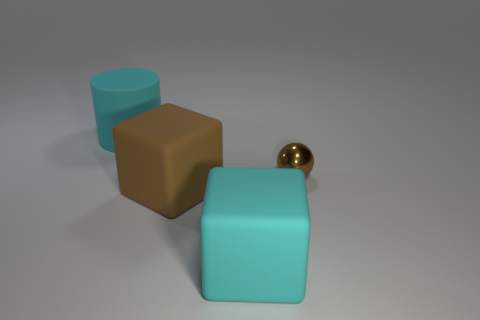There is a small metal thing on the right side of the large cyan thing that is in front of the large brown rubber cube; what is its color?
Your answer should be compact. Brown. How many other things are the same material as the small thing?
Provide a short and direct response. 0. Are there an equal number of small metal objects that are left of the cyan matte cylinder and large brown shiny cylinders?
Keep it short and to the point. Yes. What is the material of the big block behind the large cyan thing on the right side of the cylinder that is on the left side of the ball?
Your response must be concise. Rubber. There is a metal object to the right of the big matte cylinder; what is its color?
Provide a succinct answer. Brown. Is there anything else that is the same shape as the small shiny object?
Provide a short and direct response. No. How big is the cyan thing in front of the big cyan cylinder behind the brown shiny ball?
Keep it short and to the point. Large. Are there the same number of tiny balls that are in front of the brown matte thing and tiny brown objects in front of the metallic ball?
Your response must be concise. Yes. Is there any other thing that has the same size as the brown ball?
Provide a short and direct response. No. There is another cube that is the same material as the brown cube; what color is it?
Offer a terse response. Cyan. 